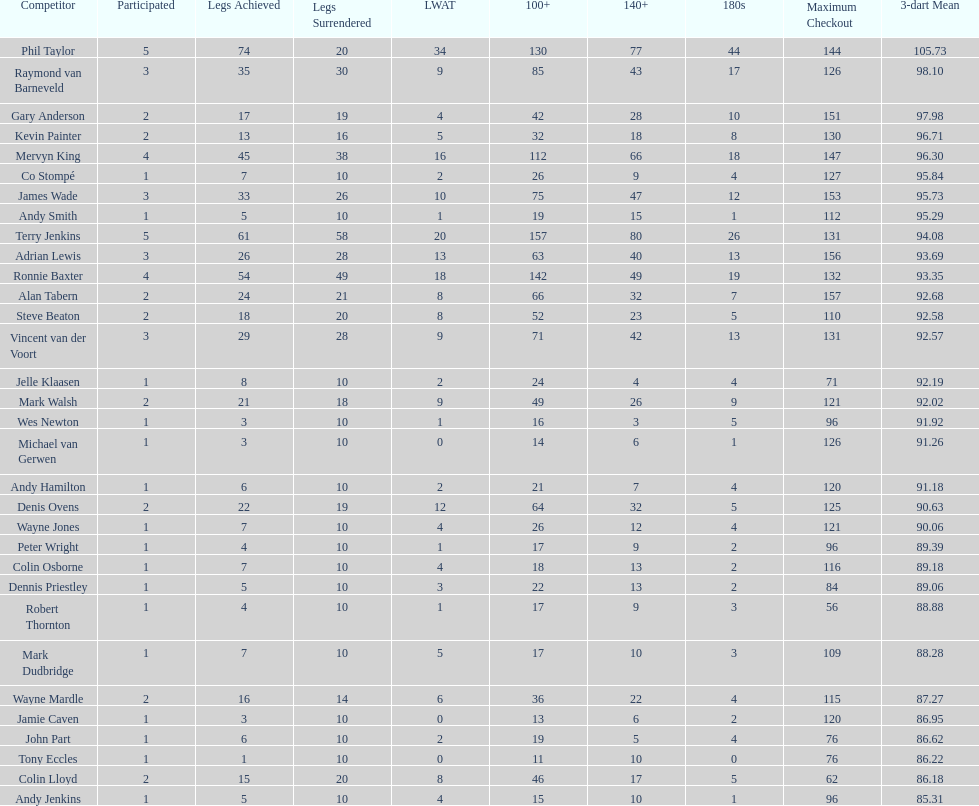How many players in the 2009 world matchplay won at least 30 legs? 6. 